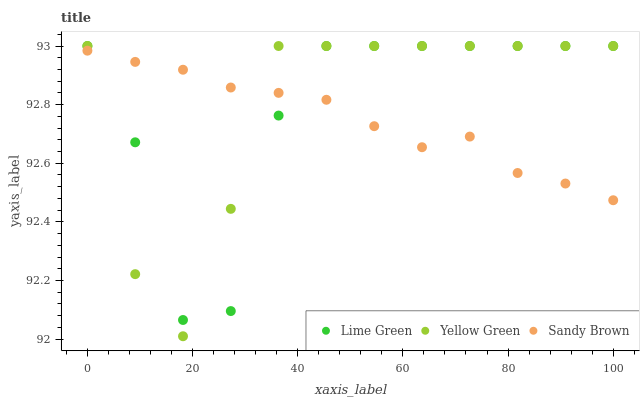Does Sandy Brown have the minimum area under the curve?
Answer yes or no. Yes. Does Yellow Green have the maximum area under the curve?
Answer yes or no. Yes. Does Lime Green have the minimum area under the curve?
Answer yes or no. No. Does Lime Green have the maximum area under the curve?
Answer yes or no. No. Is Sandy Brown the smoothest?
Answer yes or no. Yes. Is Lime Green the roughest?
Answer yes or no. Yes. Is Yellow Green the smoothest?
Answer yes or no. No. Is Yellow Green the roughest?
Answer yes or no. No. Does Yellow Green have the lowest value?
Answer yes or no. Yes. Does Lime Green have the lowest value?
Answer yes or no. No. Does Yellow Green have the highest value?
Answer yes or no. Yes. Does Lime Green intersect Sandy Brown?
Answer yes or no. Yes. Is Lime Green less than Sandy Brown?
Answer yes or no. No. Is Lime Green greater than Sandy Brown?
Answer yes or no. No. 